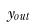Convert formula to latex. <formula><loc_0><loc_0><loc_500><loc_500>y _ { o u t }</formula> 